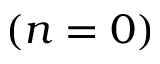Convert formula to latex. <formula><loc_0><loc_0><loc_500><loc_500>( n = 0 )</formula> 